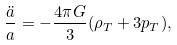<formula> <loc_0><loc_0><loc_500><loc_500>\frac { \ddot { a } } { a } = - \frac { 4 \pi G } { 3 } ( \rho _ { T } + 3 p _ { T } ) ,</formula> 